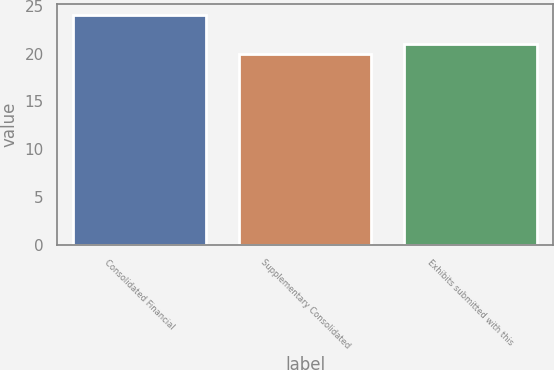Convert chart. <chart><loc_0><loc_0><loc_500><loc_500><bar_chart><fcel>Consolidated Financial<fcel>Supplementary Consolidated<fcel>Exhibits submitted with this<nl><fcel>24<fcel>20<fcel>21<nl></chart> 